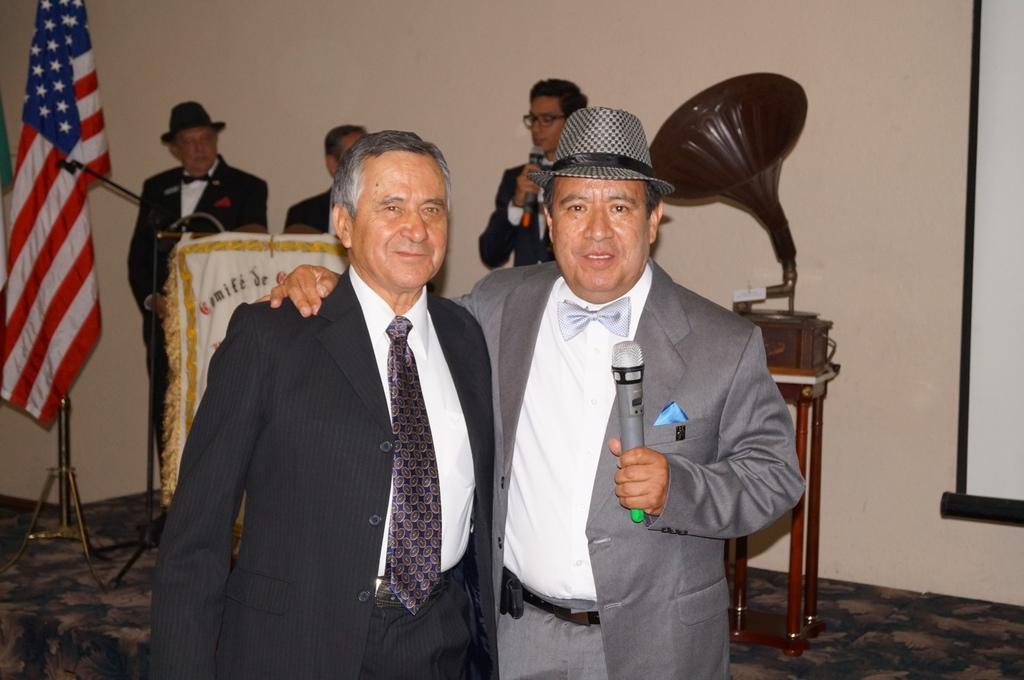In one or two sentences, can you explain what this image depicts? In this image I can see a person wearing black colored blazer and another person wearing grey colored blazer are standing and I can see one of them is holding a microphone in his hands. In the background I can see few other persons standing, few microphones, a flag, a musical instrument and a cream colored wall. 